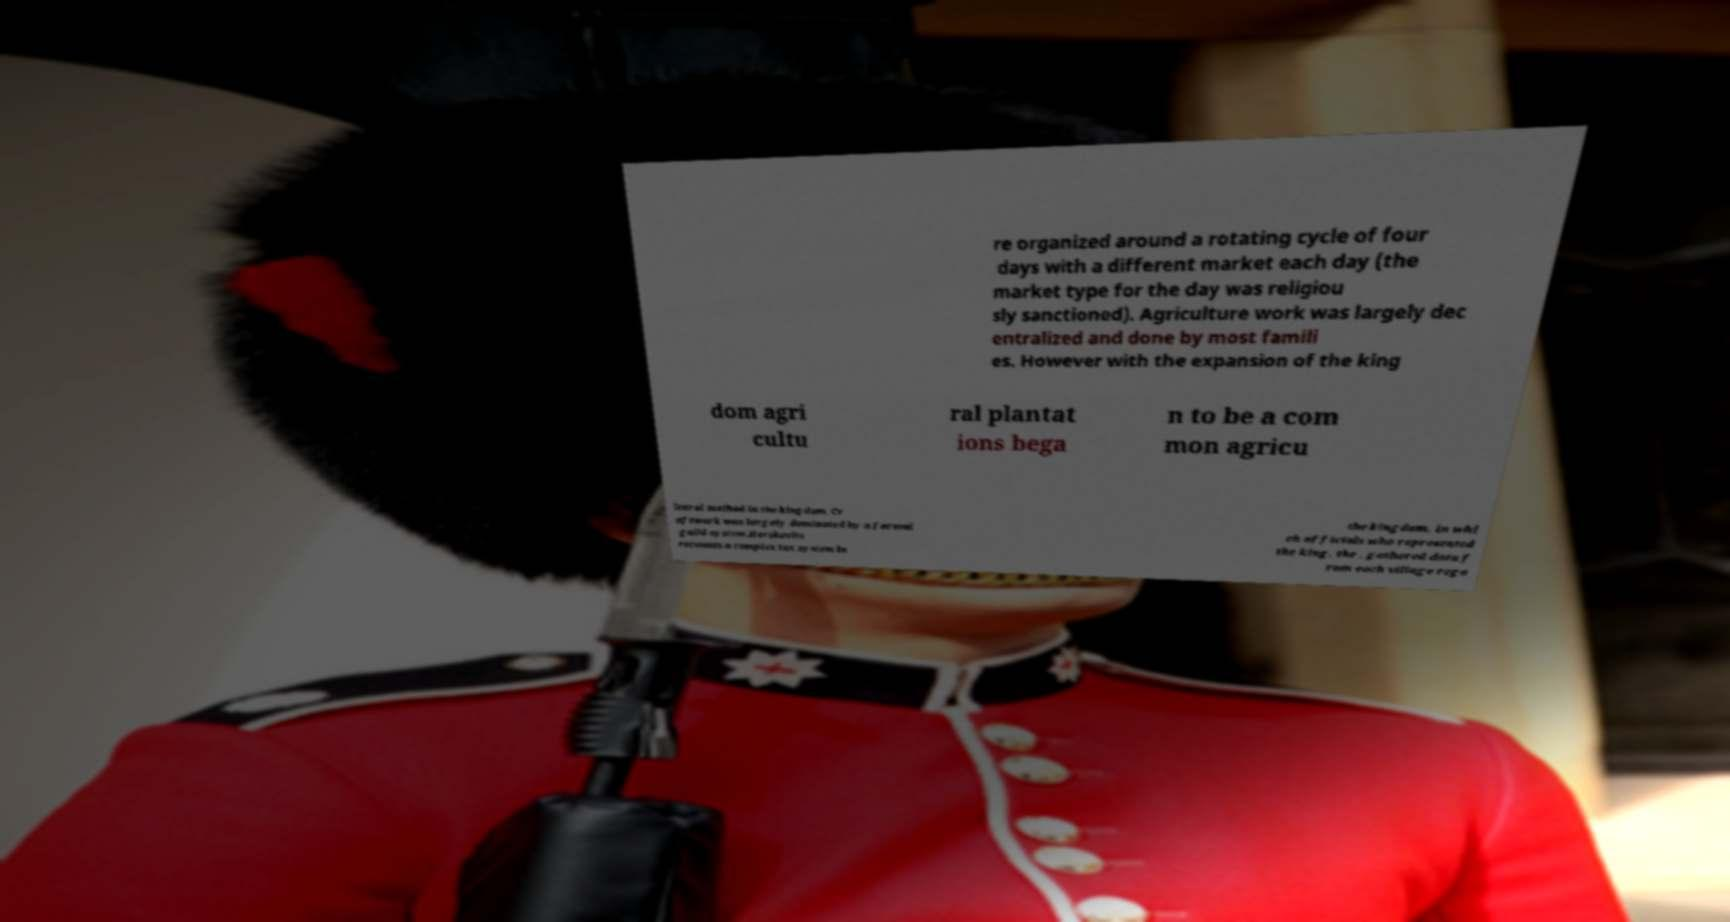Please read and relay the text visible in this image. What does it say? re organized around a rotating cycle of four days with a different market each day (the market type for the day was religiou sly sanctioned). Agriculture work was largely dec entralized and done by most famili es. However with the expansion of the king dom agri cultu ral plantat ions bega n to be a com mon agricu ltural method in the kingdom. Cr aftwork was largely dominated by a formal guild system.Herskovits recounts a complex tax system in the kingdom, in whi ch officials who represented the king, the , gathered data f rom each village rega 